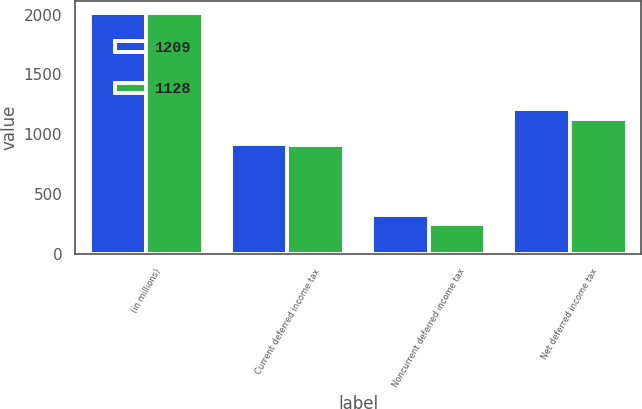Convert chart to OTSL. <chart><loc_0><loc_0><loc_500><loc_500><stacked_bar_chart><ecel><fcel>(in millions)<fcel>Current deferred income tax<fcel>Noncurrent deferred income tax<fcel>Net deferred income tax<nl><fcel>1209<fcel>2014<fcel>918<fcel>324<fcel>1209<nl><fcel>1128<fcel>2013<fcel>908<fcel>252<fcel>1128<nl></chart> 